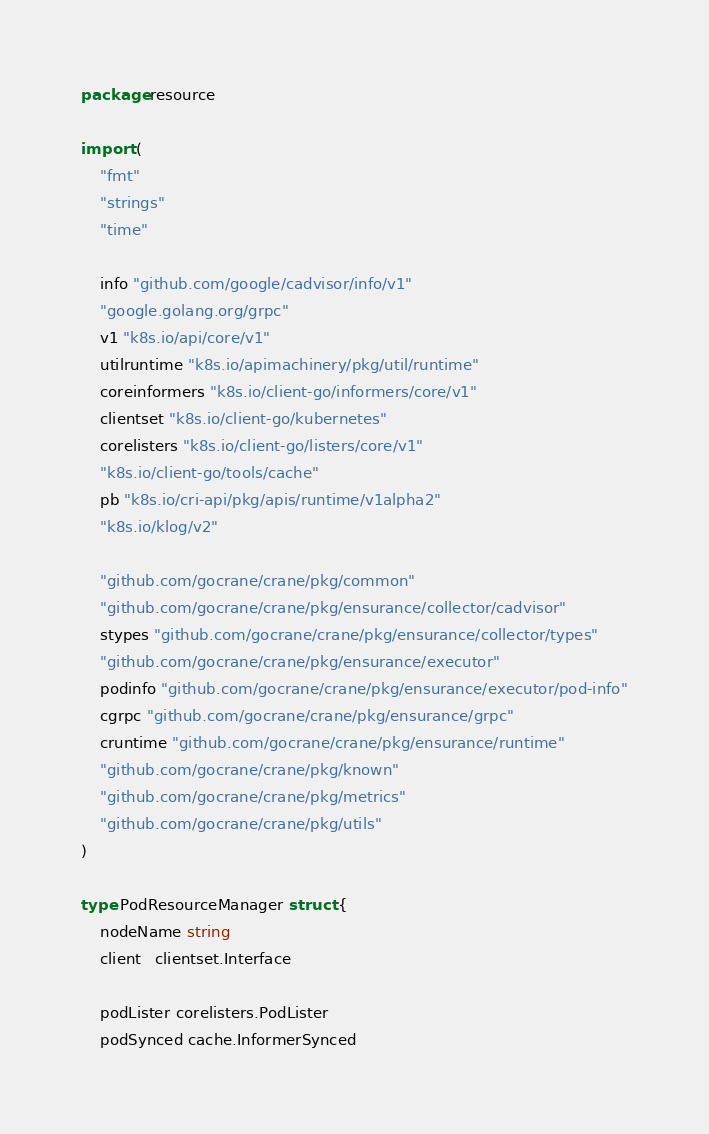Convert code to text. <code><loc_0><loc_0><loc_500><loc_500><_Go_>package resource

import (
	"fmt"
	"strings"
	"time"

	info "github.com/google/cadvisor/info/v1"
	"google.golang.org/grpc"
	v1 "k8s.io/api/core/v1"
	utilruntime "k8s.io/apimachinery/pkg/util/runtime"
	coreinformers "k8s.io/client-go/informers/core/v1"
	clientset "k8s.io/client-go/kubernetes"
	corelisters "k8s.io/client-go/listers/core/v1"
	"k8s.io/client-go/tools/cache"
	pb "k8s.io/cri-api/pkg/apis/runtime/v1alpha2"
	"k8s.io/klog/v2"

	"github.com/gocrane/crane/pkg/common"
	"github.com/gocrane/crane/pkg/ensurance/collector/cadvisor"
	stypes "github.com/gocrane/crane/pkg/ensurance/collector/types"
	"github.com/gocrane/crane/pkg/ensurance/executor"
	podinfo "github.com/gocrane/crane/pkg/ensurance/executor/pod-info"
	cgrpc "github.com/gocrane/crane/pkg/ensurance/grpc"
	cruntime "github.com/gocrane/crane/pkg/ensurance/runtime"
	"github.com/gocrane/crane/pkg/known"
	"github.com/gocrane/crane/pkg/metrics"
	"github.com/gocrane/crane/pkg/utils"
)

type PodResourceManager struct {
	nodeName string
	client   clientset.Interface

	podLister corelisters.PodLister
	podSynced cache.InformerSynced
</code> 